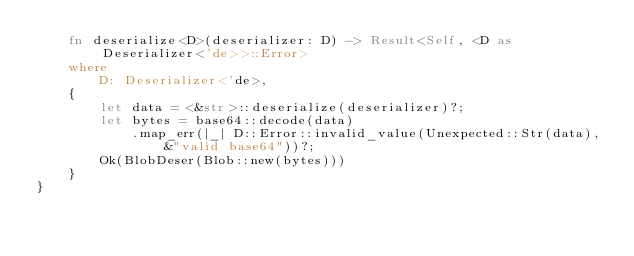<code> <loc_0><loc_0><loc_500><loc_500><_Rust_>    fn deserialize<D>(deserializer: D) -> Result<Self, <D as Deserializer<'de>>::Error>
    where
        D: Deserializer<'de>,
    {
        let data = <&str>::deserialize(deserializer)?;
        let bytes = base64::decode(data)
            .map_err(|_| D::Error::invalid_value(Unexpected::Str(data), &"valid base64"))?;
        Ok(BlobDeser(Blob::new(bytes)))
    }
}
</code> 